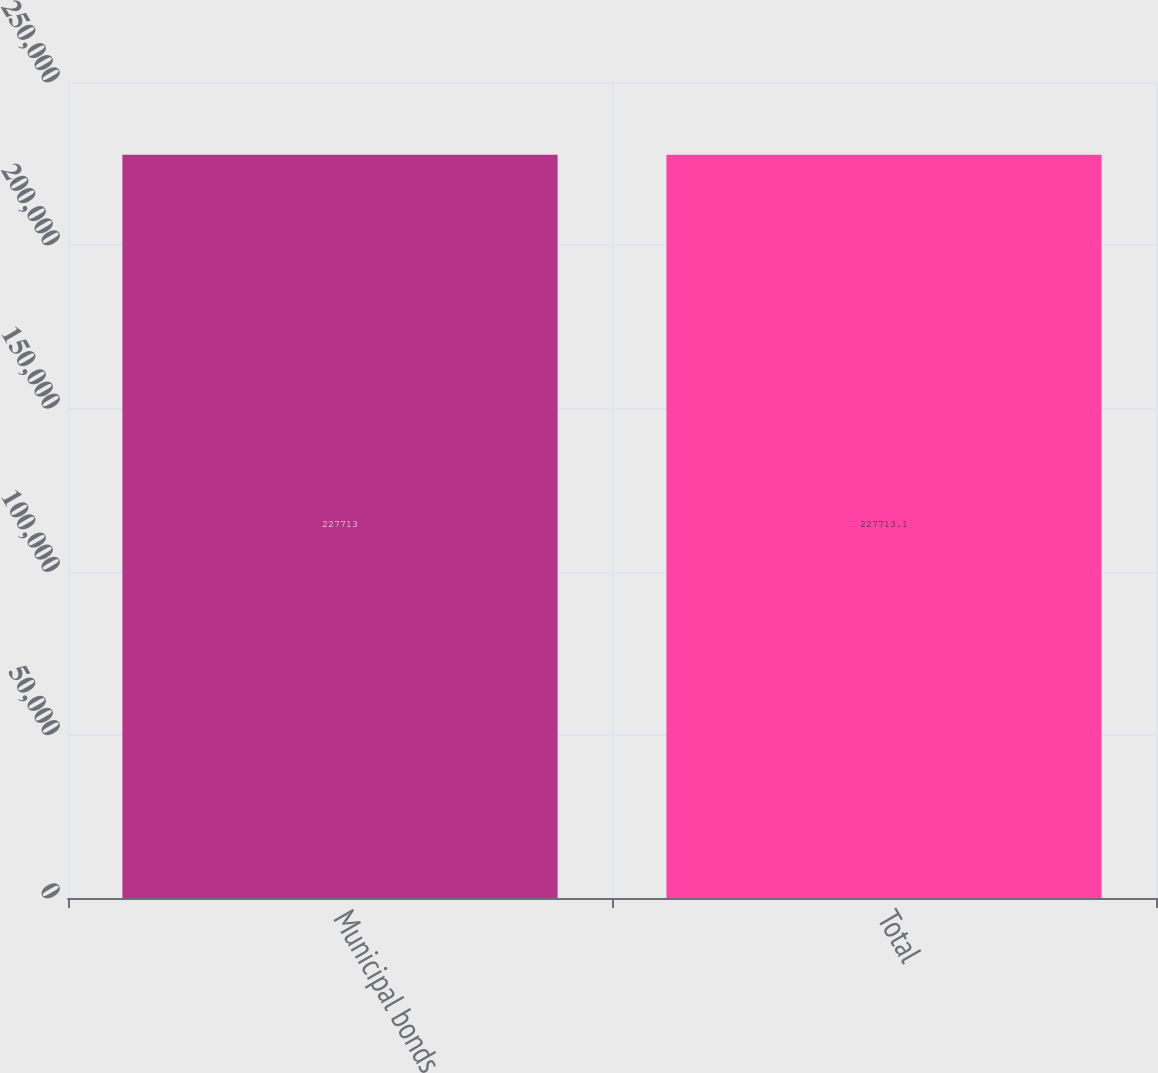Convert chart. <chart><loc_0><loc_0><loc_500><loc_500><bar_chart><fcel>Municipal bonds<fcel>Total<nl><fcel>227713<fcel>227713<nl></chart> 